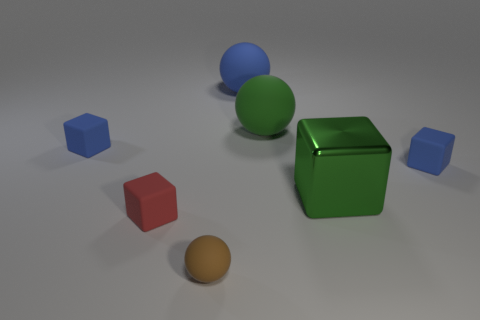Are there any other things that are made of the same material as the big green cube?
Ensure brevity in your answer.  No. Does the green cube on the right side of the tiny red rubber object have the same size as the sphere that is right of the blue rubber sphere?
Your response must be concise. Yes. What is the size of the red object that is made of the same material as the brown ball?
Ensure brevity in your answer.  Small. How many tiny cubes are behind the red object and on the left side of the brown rubber ball?
Provide a short and direct response. 1. What number of things are red things or large balls that are right of the blue rubber ball?
Offer a terse response. 2. What is the color of the small rubber cube that is to the right of the green block?
Make the answer very short. Blue. What number of things are green cubes behind the tiny matte sphere or brown matte spheres?
Provide a succinct answer. 2. There is a ball that is the same size as the red block; what is its color?
Your answer should be compact. Brown. Are there more objects right of the small red object than blue balls?
Keep it short and to the point. Yes. Do the small rubber cube that is on the left side of the small red rubber object and the matte thing that is behind the green rubber sphere have the same color?
Provide a short and direct response. Yes. 